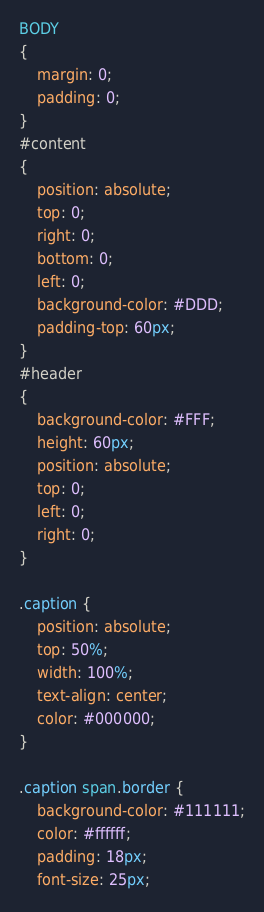Convert code to text. <code><loc_0><loc_0><loc_500><loc_500><_CSS_>BODY
{
    margin: 0;
    padding: 0;
}
#content
{
    position: absolute;
    top: 0;
    right: 0;
    bottom: 0;
    left: 0;
    background-color: #DDD;
    padding-top: 60px;
}
#header
{
    background-color: #FFF;
    height: 60px;
    position: absolute;
    top: 0;
    left: 0;
    right: 0;
}

.caption {
    position: absolute;
    top: 50%;
    width: 100%;
    text-align: center;
    color: #000000;
}

.caption span.border {
    background-color: #111111;
    color: #ffffff;
    padding: 18px;
    font-size: 25px;</code> 